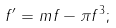Convert formula to latex. <formula><loc_0><loc_0><loc_500><loc_500>f ^ { \prime } = m f - \pi f ^ { 3 } ;</formula> 